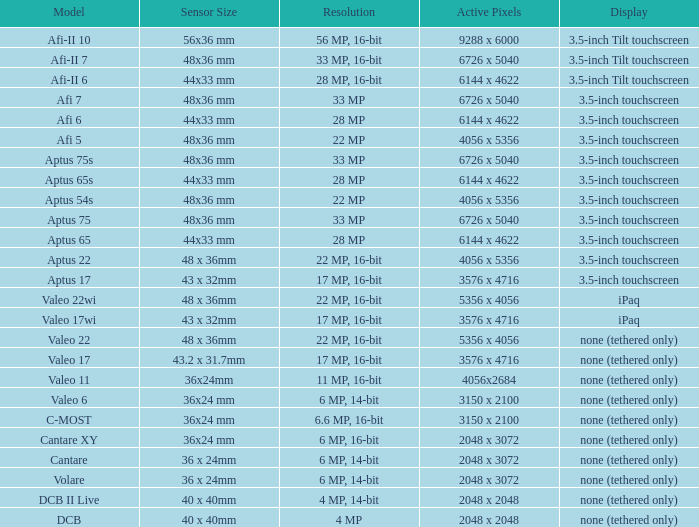Which model is equipped with a sensor measuring 48x36 mm, a pixel count of 6726 x 5040, and a resolution of 33 million pixels? Afi 7, Aptus 75s, Aptus 75. 